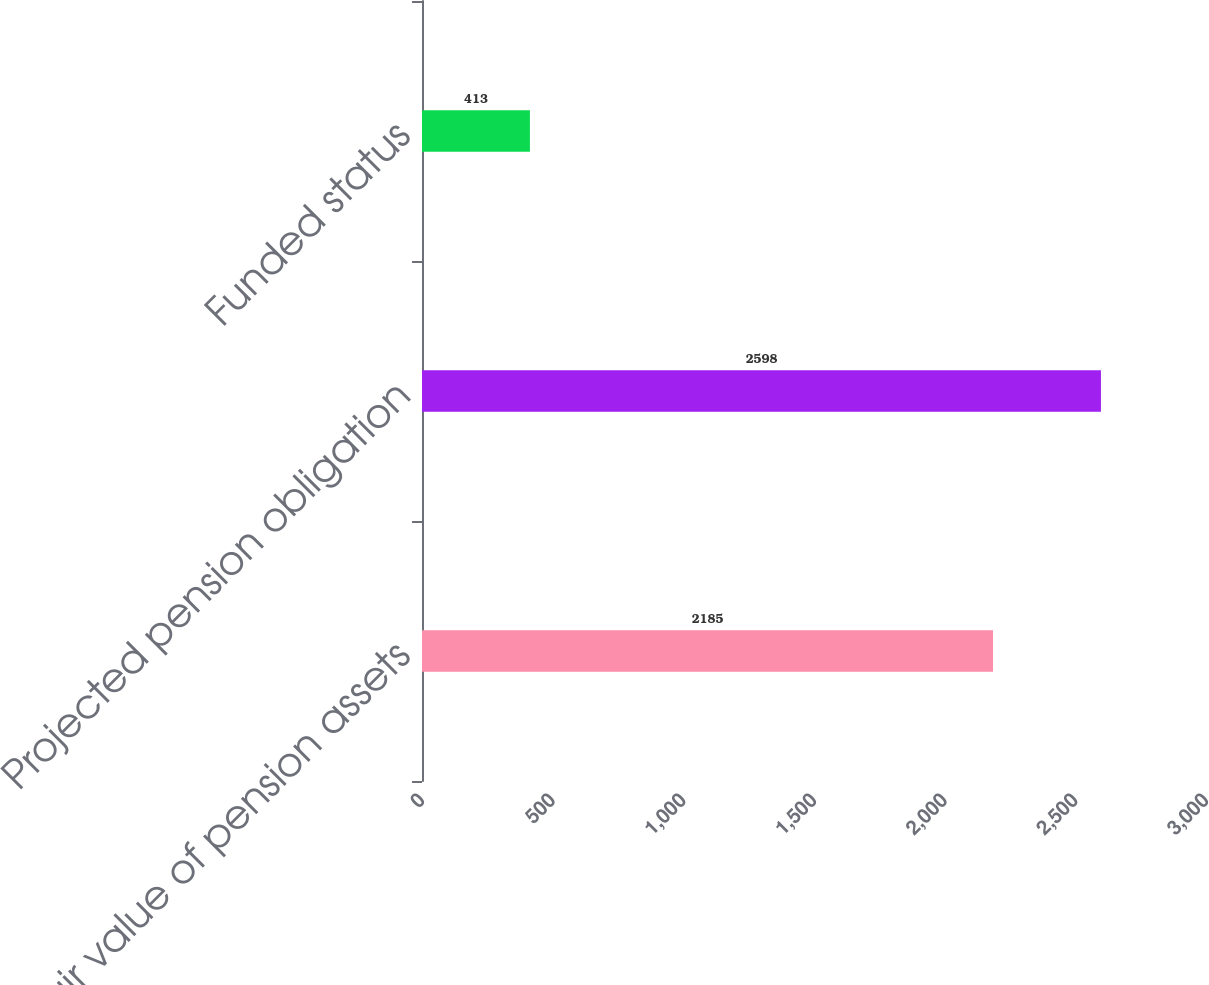Convert chart. <chart><loc_0><loc_0><loc_500><loc_500><bar_chart><fcel>Fair value of pension assets<fcel>Projected pension obligation<fcel>Funded status<nl><fcel>2185<fcel>2598<fcel>413<nl></chart> 